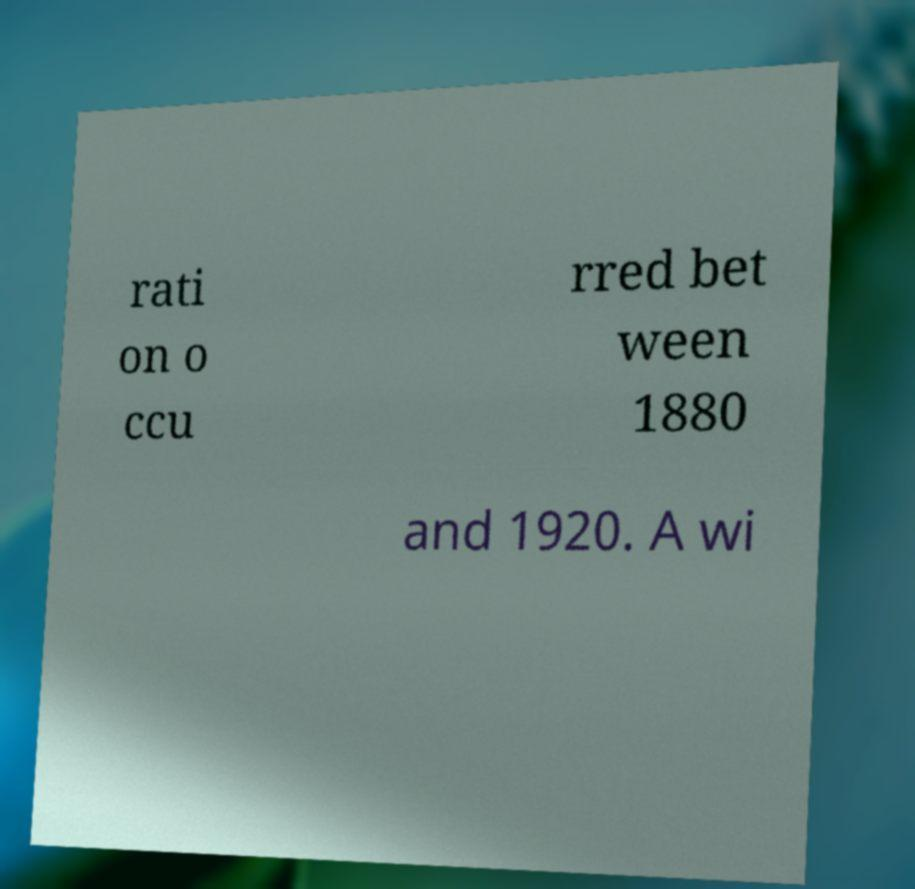I need the written content from this picture converted into text. Can you do that? rati on o ccu rred bet ween 1880 and 1920. A wi 